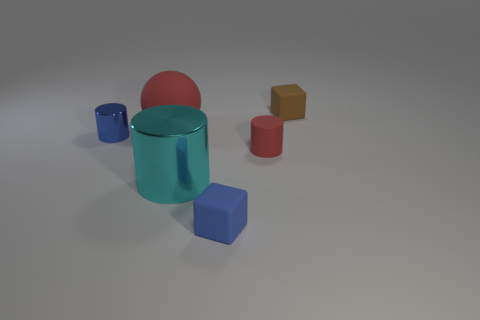Do the cube in front of the large red ball and the small cylinder that is to the left of the tiny red matte cylinder have the same color?
Your answer should be compact. Yes. Is there any other thing of the same color as the big shiny object?
Provide a succinct answer. No. Are there fewer small blocks behind the blue metallic cylinder than blue matte cylinders?
Provide a short and direct response. No. What number of brown things are there?
Offer a terse response. 1. Do the small blue metallic thing and the red object to the left of the blue rubber thing have the same shape?
Your answer should be compact. No. Is the number of big metallic things behind the small red matte cylinder less than the number of tiny red matte objects on the left side of the small brown block?
Ensure brevity in your answer.  Yes. Are there any other things that have the same shape as the big red matte thing?
Make the answer very short. No. Is the brown thing the same shape as the blue shiny thing?
Your answer should be very brief. No. What size is the cyan shiny thing?
Keep it short and to the point. Large. There is a object that is behind the small blue metallic cylinder and in front of the brown object; what color is it?
Provide a succinct answer. Red. 